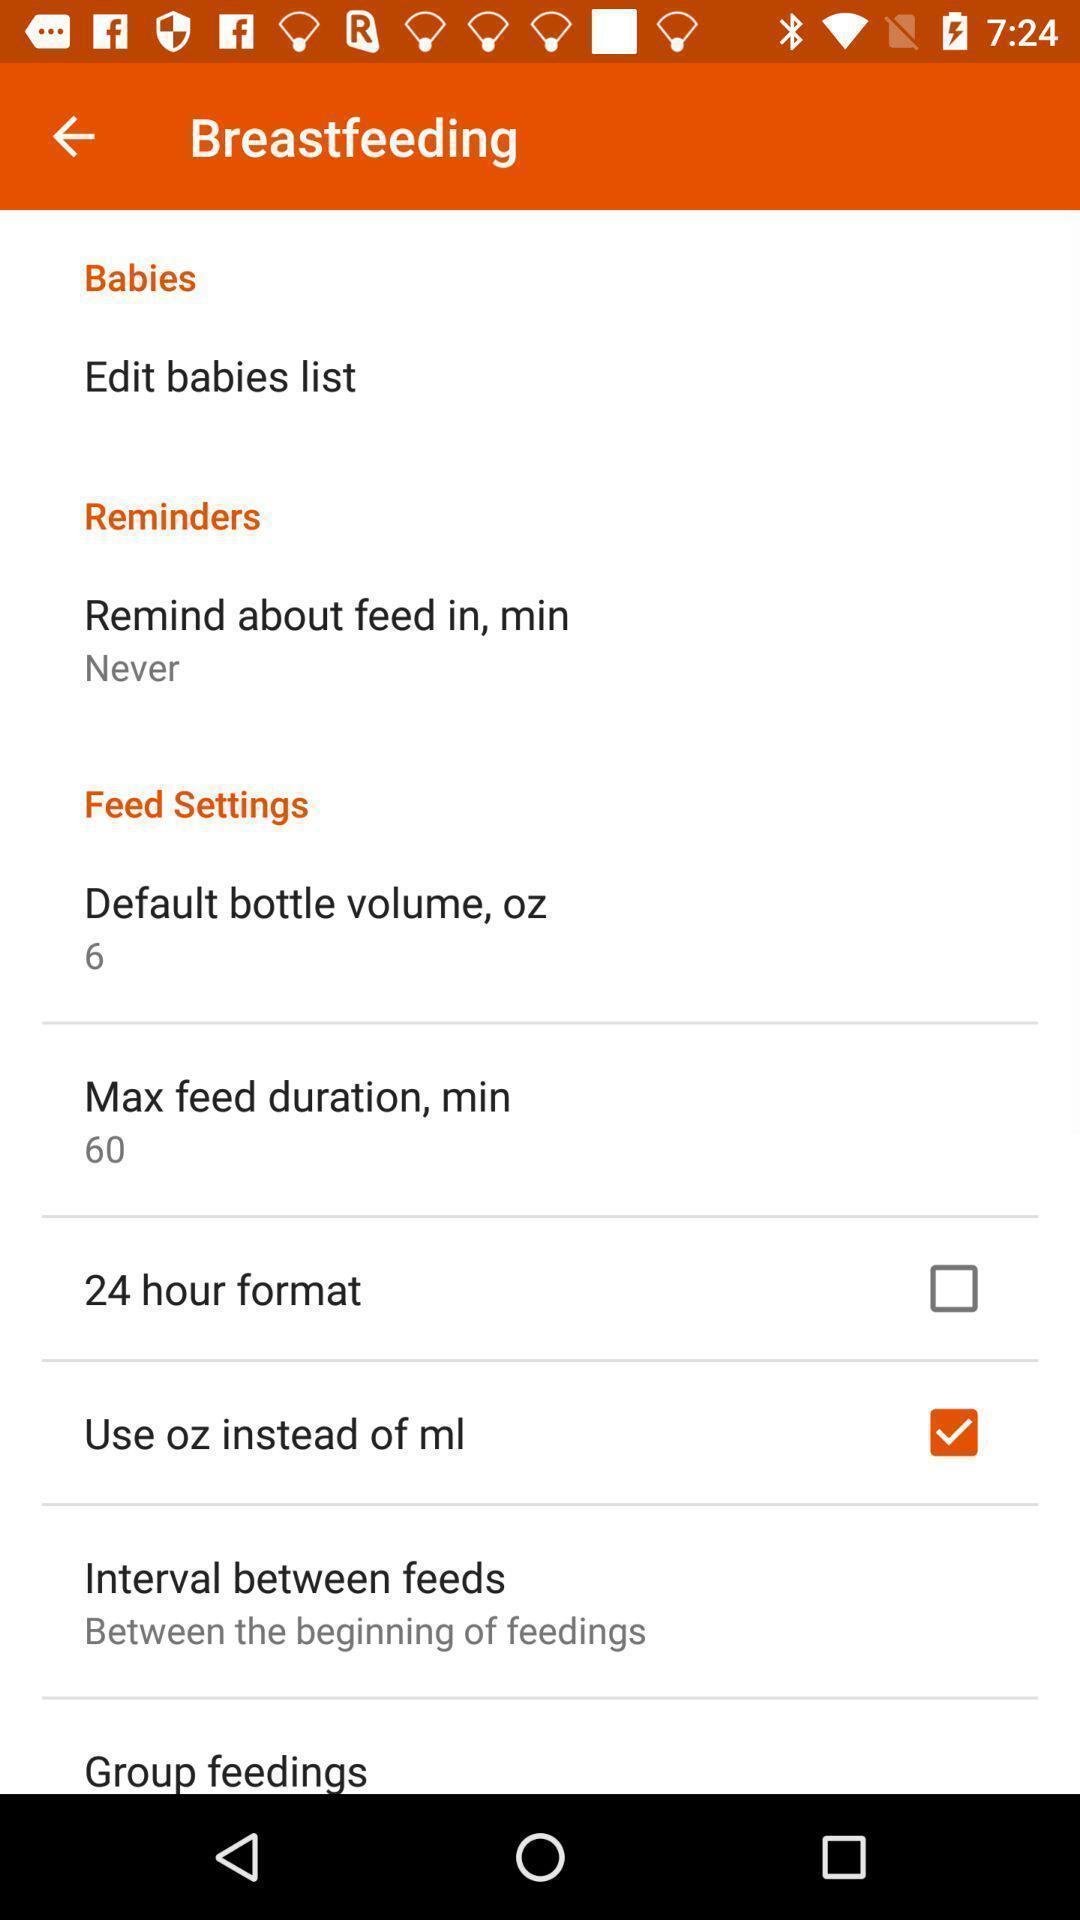Summarize the information in this screenshot. Setting page of breastfeeding. 